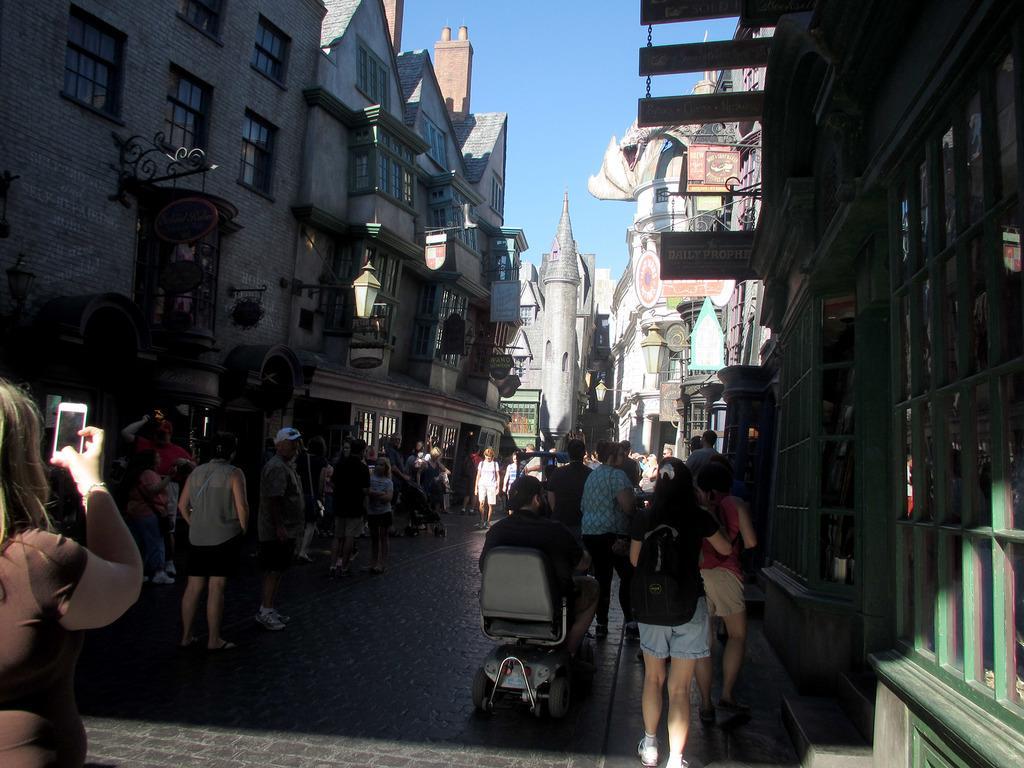Can you describe this image briefly? In this picture we can see a person sitting on a chair. There is a woman holding a phone in her hand on the left side. We can see a few people on the path. We can see poles, street lights and buildings in the background. Sky is blue in color. 